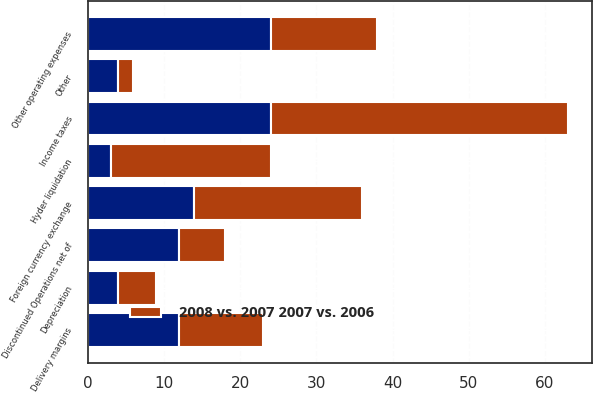Convert chart. <chart><loc_0><loc_0><loc_500><loc_500><stacked_bar_chart><ecel><fcel>Delivery margins<fcel>Other operating expenses<fcel>Depreciation<fcel>Income taxes<fcel>Foreign currency exchange<fcel>Hyder liquidation<fcel>Other<fcel>Discontinued Operations net of<nl><fcel>nan<fcel>12<fcel>24<fcel>4<fcel>24<fcel>14<fcel>3<fcel>4<fcel>12<nl><fcel>2008 vs. 2007 2007 vs. 2006<fcel>11<fcel>14<fcel>5<fcel>39<fcel>22<fcel>21<fcel>2<fcel>6<nl></chart> 